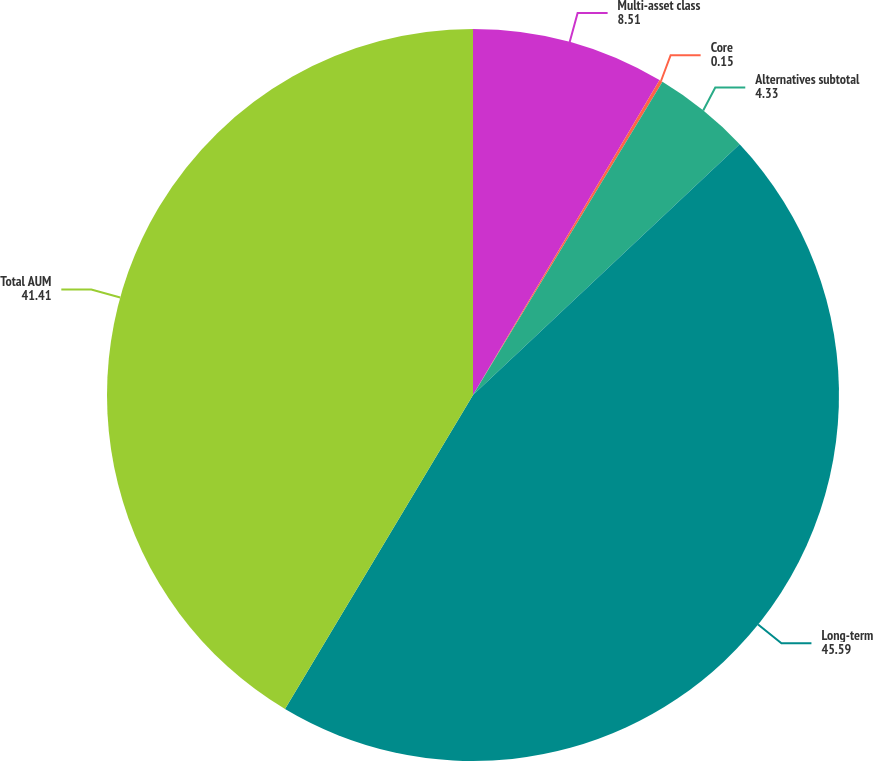<chart> <loc_0><loc_0><loc_500><loc_500><pie_chart><fcel>Multi-asset class<fcel>Core<fcel>Alternatives subtotal<fcel>Long-term<fcel>Total AUM<nl><fcel>8.51%<fcel>0.15%<fcel>4.33%<fcel>45.59%<fcel>41.41%<nl></chart> 